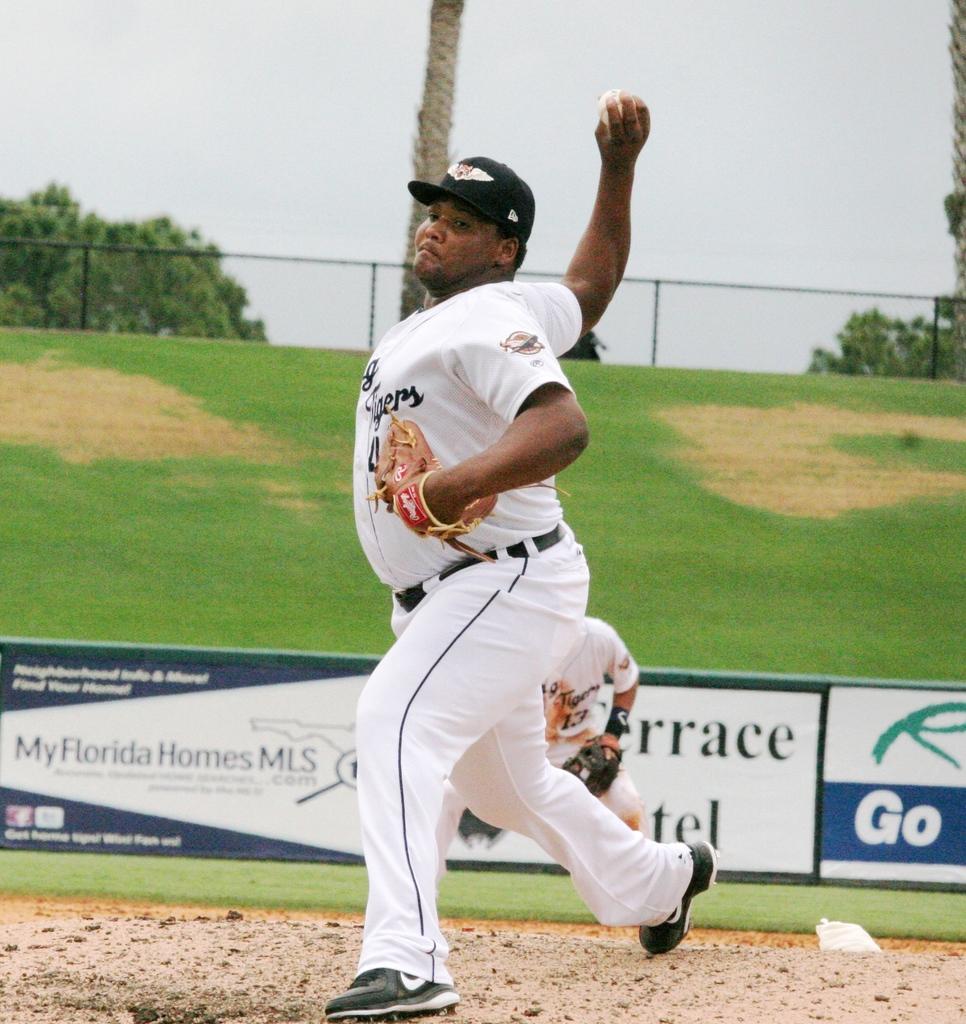What state is this game being played in?
Keep it short and to the point. Florida. What is written on those advert boards?
Provide a short and direct response. My florida homes mls. 